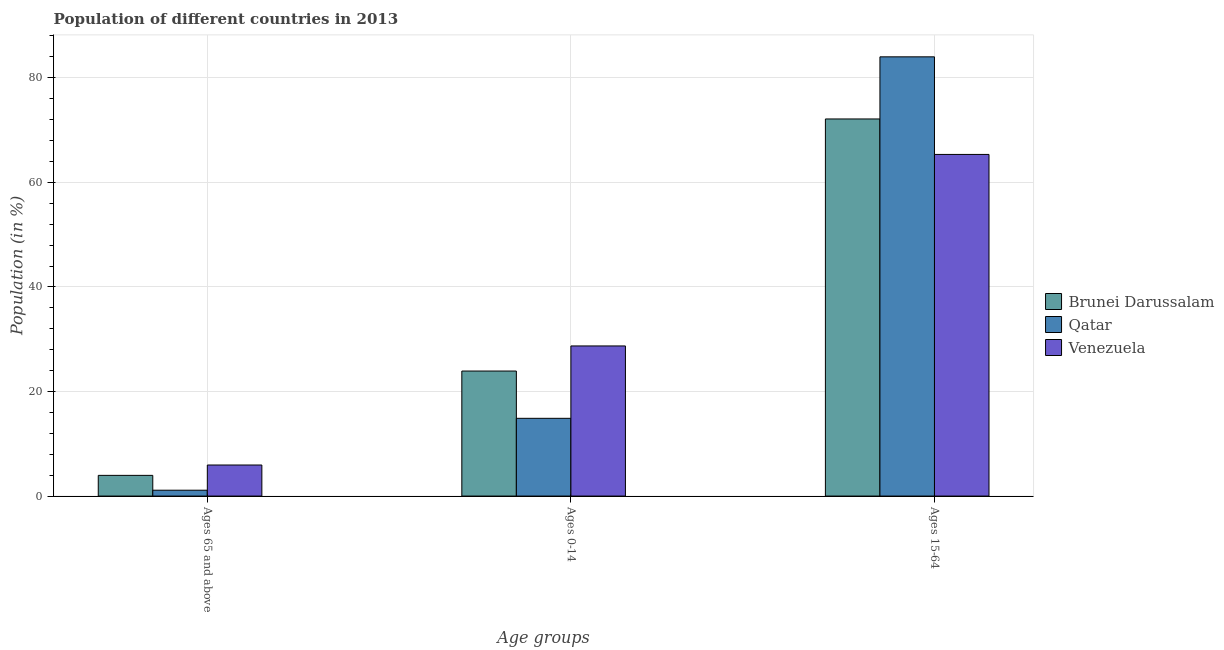How many different coloured bars are there?
Keep it short and to the point. 3. Are the number of bars per tick equal to the number of legend labels?
Your response must be concise. Yes. Are the number of bars on each tick of the X-axis equal?
Your answer should be very brief. Yes. How many bars are there on the 3rd tick from the left?
Keep it short and to the point. 3. What is the label of the 2nd group of bars from the left?
Provide a short and direct response. Ages 0-14. What is the percentage of population within the age-group 15-64 in Qatar?
Make the answer very short. 84.01. Across all countries, what is the maximum percentage of population within the age-group 0-14?
Your answer should be very brief. 28.71. Across all countries, what is the minimum percentage of population within the age-group 15-64?
Provide a short and direct response. 65.34. In which country was the percentage of population within the age-group of 65 and above maximum?
Your answer should be very brief. Venezuela. In which country was the percentage of population within the age-group of 65 and above minimum?
Provide a short and direct response. Qatar. What is the total percentage of population within the age-group 0-14 in the graph?
Ensure brevity in your answer.  67.5. What is the difference between the percentage of population within the age-group 15-64 in Qatar and that in Venezuela?
Your answer should be compact. 18.67. What is the difference between the percentage of population within the age-group 0-14 in Qatar and the percentage of population within the age-group of 65 and above in Brunei Darussalam?
Your response must be concise. 10.91. What is the average percentage of population within the age-group of 65 and above per country?
Offer a terse response. 3.67. What is the difference between the percentage of population within the age-group 15-64 and percentage of population within the age-group 0-14 in Qatar?
Offer a very short reply. 69.14. In how many countries, is the percentage of population within the age-group 15-64 greater than 32 %?
Your answer should be very brief. 3. What is the ratio of the percentage of population within the age-group 15-64 in Qatar to that in Brunei Darussalam?
Make the answer very short. 1.16. What is the difference between the highest and the second highest percentage of population within the age-group 15-64?
Keep it short and to the point. 11.88. What is the difference between the highest and the lowest percentage of population within the age-group 15-64?
Ensure brevity in your answer.  18.67. Is the sum of the percentage of population within the age-group of 65 and above in Qatar and Venezuela greater than the maximum percentage of population within the age-group 15-64 across all countries?
Keep it short and to the point. No. What does the 3rd bar from the left in Ages 0-14 represents?
Offer a very short reply. Venezuela. What does the 1st bar from the right in Ages 0-14 represents?
Offer a very short reply. Venezuela. What is the difference between two consecutive major ticks on the Y-axis?
Your answer should be very brief. 20. Are the values on the major ticks of Y-axis written in scientific E-notation?
Give a very brief answer. No. Does the graph contain any zero values?
Offer a terse response. No. How many legend labels are there?
Provide a short and direct response. 3. How are the legend labels stacked?
Provide a short and direct response. Vertical. What is the title of the graph?
Ensure brevity in your answer.  Population of different countries in 2013. Does "Namibia" appear as one of the legend labels in the graph?
Provide a succinct answer. No. What is the label or title of the X-axis?
Give a very brief answer. Age groups. What is the label or title of the Y-axis?
Your response must be concise. Population (in %). What is the Population (in %) of Brunei Darussalam in Ages 65 and above?
Your response must be concise. 3.96. What is the Population (in %) in Qatar in Ages 65 and above?
Provide a short and direct response. 1.12. What is the Population (in %) in Venezuela in Ages 65 and above?
Your answer should be very brief. 5.94. What is the Population (in %) of Brunei Darussalam in Ages 0-14?
Keep it short and to the point. 23.91. What is the Population (in %) in Qatar in Ages 0-14?
Keep it short and to the point. 14.87. What is the Population (in %) of Venezuela in Ages 0-14?
Your response must be concise. 28.71. What is the Population (in %) in Brunei Darussalam in Ages 15-64?
Offer a very short reply. 72.13. What is the Population (in %) of Qatar in Ages 15-64?
Provide a short and direct response. 84.01. What is the Population (in %) of Venezuela in Ages 15-64?
Offer a terse response. 65.34. Across all Age groups, what is the maximum Population (in %) of Brunei Darussalam?
Offer a terse response. 72.13. Across all Age groups, what is the maximum Population (in %) in Qatar?
Your answer should be compact. 84.01. Across all Age groups, what is the maximum Population (in %) of Venezuela?
Give a very brief answer. 65.34. Across all Age groups, what is the minimum Population (in %) of Brunei Darussalam?
Your answer should be compact. 3.96. Across all Age groups, what is the minimum Population (in %) in Qatar?
Keep it short and to the point. 1.12. Across all Age groups, what is the minimum Population (in %) of Venezuela?
Your response must be concise. 5.94. What is the difference between the Population (in %) of Brunei Darussalam in Ages 65 and above and that in Ages 0-14?
Offer a terse response. -19.95. What is the difference between the Population (in %) in Qatar in Ages 65 and above and that in Ages 0-14?
Offer a terse response. -13.75. What is the difference between the Population (in %) of Venezuela in Ages 65 and above and that in Ages 0-14?
Ensure brevity in your answer.  -22.77. What is the difference between the Population (in %) of Brunei Darussalam in Ages 65 and above and that in Ages 15-64?
Give a very brief answer. -68.17. What is the difference between the Population (in %) in Qatar in Ages 65 and above and that in Ages 15-64?
Your answer should be very brief. -82.89. What is the difference between the Population (in %) in Venezuela in Ages 65 and above and that in Ages 15-64?
Keep it short and to the point. -59.4. What is the difference between the Population (in %) in Brunei Darussalam in Ages 0-14 and that in Ages 15-64?
Provide a succinct answer. -48.22. What is the difference between the Population (in %) of Qatar in Ages 0-14 and that in Ages 15-64?
Offer a terse response. -69.14. What is the difference between the Population (in %) of Venezuela in Ages 0-14 and that in Ages 15-64?
Ensure brevity in your answer.  -36.63. What is the difference between the Population (in %) in Brunei Darussalam in Ages 65 and above and the Population (in %) in Qatar in Ages 0-14?
Your answer should be compact. -10.91. What is the difference between the Population (in %) of Brunei Darussalam in Ages 65 and above and the Population (in %) of Venezuela in Ages 0-14?
Make the answer very short. -24.76. What is the difference between the Population (in %) of Qatar in Ages 65 and above and the Population (in %) of Venezuela in Ages 0-14?
Your response must be concise. -27.59. What is the difference between the Population (in %) of Brunei Darussalam in Ages 65 and above and the Population (in %) of Qatar in Ages 15-64?
Offer a very short reply. -80.05. What is the difference between the Population (in %) of Brunei Darussalam in Ages 65 and above and the Population (in %) of Venezuela in Ages 15-64?
Ensure brevity in your answer.  -61.39. What is the difference between the Population (in %) in Qatar in Ages 65 and above and the Population (in %) in Venezuela in Ages 15-64?
Offer a terse response. -64.22. What is the difference between the Population (in %) in Brunei Darussalam in Ages 0-14 and the Population (in %) in Qatar in Ages 15-64?
Your response must be concise. -60.1. What is the difference between the Population (in %) in Brunei Darussalam in Ages 0-14 and the Population (in %) in Venezuela in Ages 15-64?
Make the answer very short. -41.43. What is the difference between the Population (in %) of Qatar in Ages 0-14 and the Population (in %) of Venezuela in Ages 15-64?
Ensure brevity in your answer.  -50.48. What is the average Population (in %) in Brunei Darussalam per Age groups?
Provide a succinct answer. 33.33. What is the average Population (in %) of Qatar per Age groups?
Provide a short and direct response. 33.33. What is the average Population (in %) in Venezuela per Age groups?
Your response must be concise. 33.33. What is the difference between the Population (in %) of Brunei Darussalam and Population (in %) of Qatar in Ages 65 and above?
Your answer should be compact. 2.84. What is the difference between the Population (in %) in Brunei Darussalam and Population (in %) in Venezuela in Ages 65 and above?
Provide a succinct answer. -1.98. What is the difference between the Population (in %) of Qatar and Population (in %) of Venezuela in Ages 65 and above?
Your answer should be compact. -4.82. What is the difference between the Population (in %) in Brunei Darussalam and Population (in %) in Qatar in Ages 0-14?
Give a very brief answer. 9.04. What is the difference between the Population (in %) in Brunei Darussalam and Population (in %) in Venezuela in Ages 0-14?
Your response must be concise. -4.8. What is the difference between the Population (in %) in Qatar and Population (in %) in Venezuela in Ages 0-14?
Your answer should be compact. -13.85. What is the difference between the Population (in %) in Brunei Darussalam and Population (in %) in Qatar in Ages 15-64?
Make the answer very short. -11.88. What is the difference between the Population (in %) of Brunei Darussalam and Population (in %) of Venezuela in Ages 15-64?
Keep it short and to the point. 6.78. What is the difference between the Population (in %) of Qatar and Population (in %) of Venezuela in Ages 15-64?
Give a very brief answer. 18.67. What is the ratio of the Population (in %) of Brunei Darussalam in Ages 65 and above to that in Ages 0-14?
Your answer should be compact. 0.17. What is the ratio of the Population (in %) in Qatar in Ages 65 and above to that in Ages 0-14?
Offer a terse response. 0.08. What is the ratio of the Population (in %) in Venezuela in Ages 65 and above to that in Ages 0-14?
Ensure brevity in your answer.  0.21. What is the ratio of the Population (in %) of Brunei Darussalam in Ages 65 and above to that in Ages 15-64?
Offer a very short reply. 0.05. What is the ratio of the Population (in %) of Qatar in Ages 65 and above to that in Ages 15-64?
Make the answer very short. 0.01. What is the ratio of the Population (in %) of Venezuela in Ages 65 and above to that in Ages 15-64?
Offer a terse response. 0.09. What is the ratio of the Population (in %) in Brunei Darussalam in Ages 0-14 to that in Ages 15-64?
Keep it short and to the point. 0.33. What is the ratio of the Population (in %) of Qatar in Ages 0-14 to that in Ages 15-64?
Keep it short and to the point. 0.18. What is the ratio of the Population (in %) in Venezuela in Ages 0-14 to that in Ages 15-64?
Your answer should be compact. 0.44. What is the difference between the highest and the second highest Population (in %) of Brunei Darussalam?
Provide a short and direct response. 48.22. What is the difference between the highest and the second highest Population (in %) of Qatar?
Ensure brevity in your answer.  69.14. What is the difference between the highest and the second highest Population (in %) in Venezuela?
Your answer should be compact. 36.63. What is the difference between the highest and the lowest Population (in %) in Brunei Darussalam?
Give a very brief answer. 68.17. What is the difference between the highest and the lowest Population (in %) of Qatar?
Make the answer very short. 82.89. What is the difference between the highest and the lowest Population (in %) of Venezuela?
Keep it short and to the point. 59.4. 